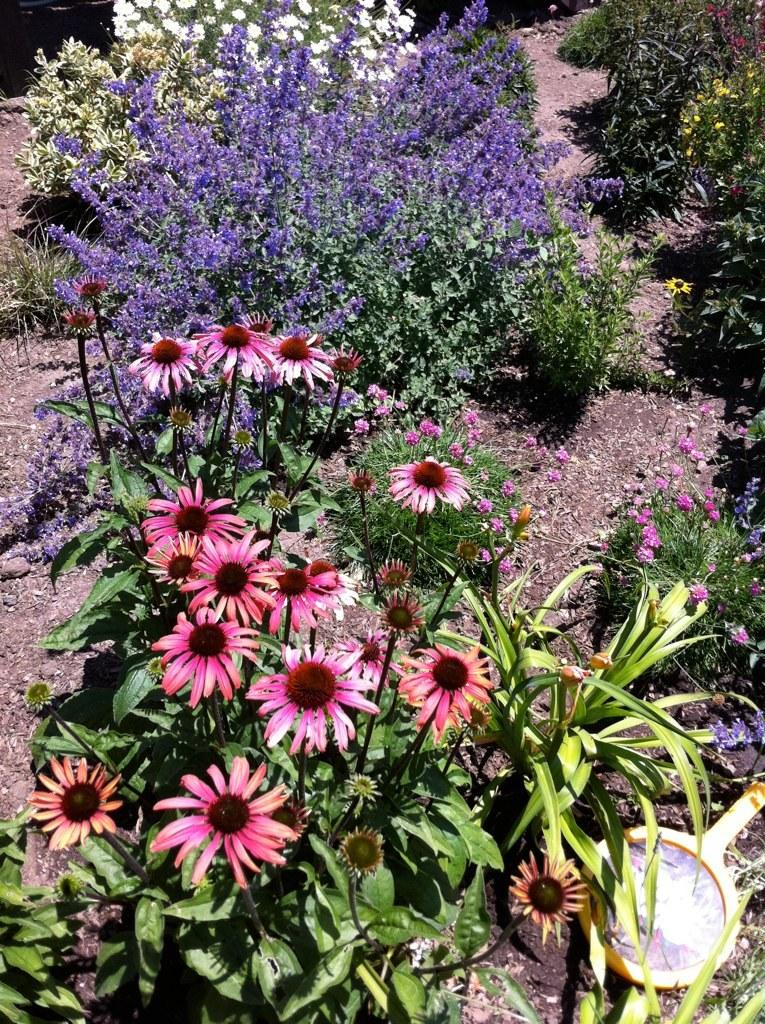What color are the flowers in the image? There are pink, violet, and white color flowers in the image. Where are the violet and white flowers located? The violet and white flowers are located at the top of the image. What else can be seen on the right side of the image? There are plants on the ground on the right side of the image. What type of substance is the cow grazing on in the image? There is no cow present in the image, so it is not possible to determine what substance the cow might be grazing on. 